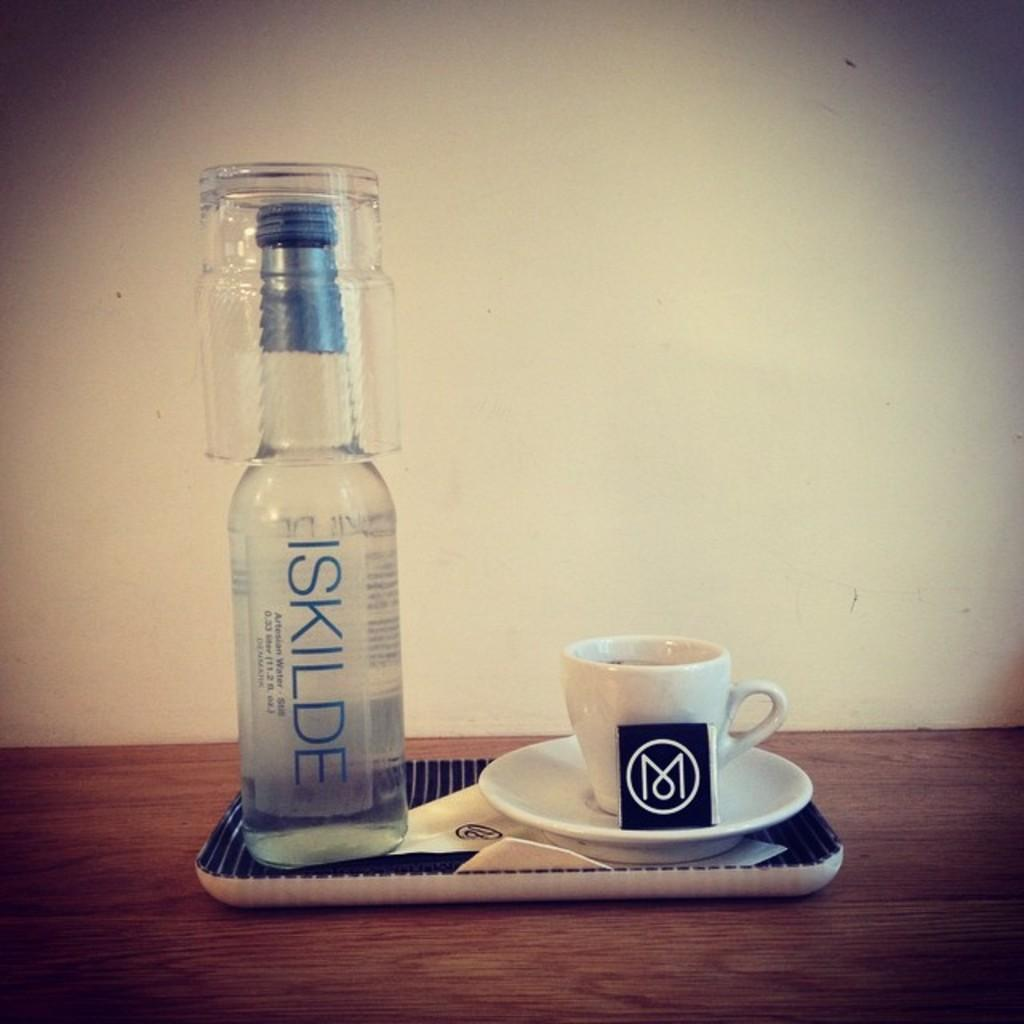<image>
Create a compact narrative representing the image presented. A bottle of Ikilde is sitting next to a coffee mug and saucer. 